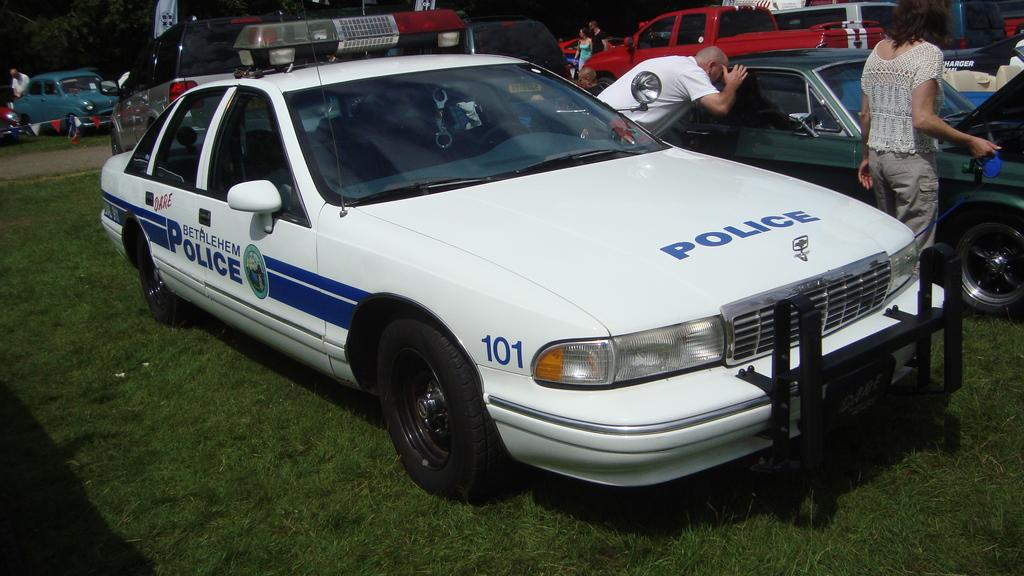What types of objects are present in the image? There are vehicles and people in the image. Where are the vehicles and people located? They are on the grass in the image. Can you describe any natural elements in the image? There is a tree in the top left corner of the image. How many cows are grazing on the grass in the image? There are no cows present in the image; it features vehicles and people on the grass. 